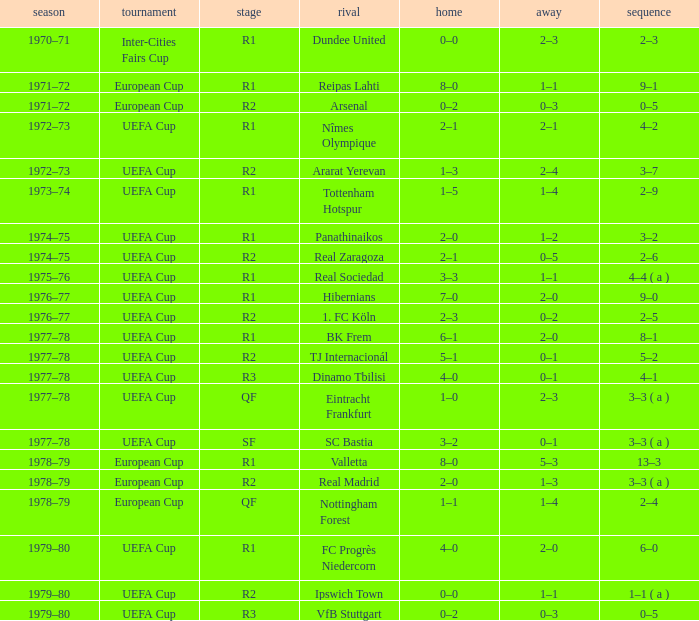Which Round has a Competition of uefa cup, and a Series of 5–2? R2. 